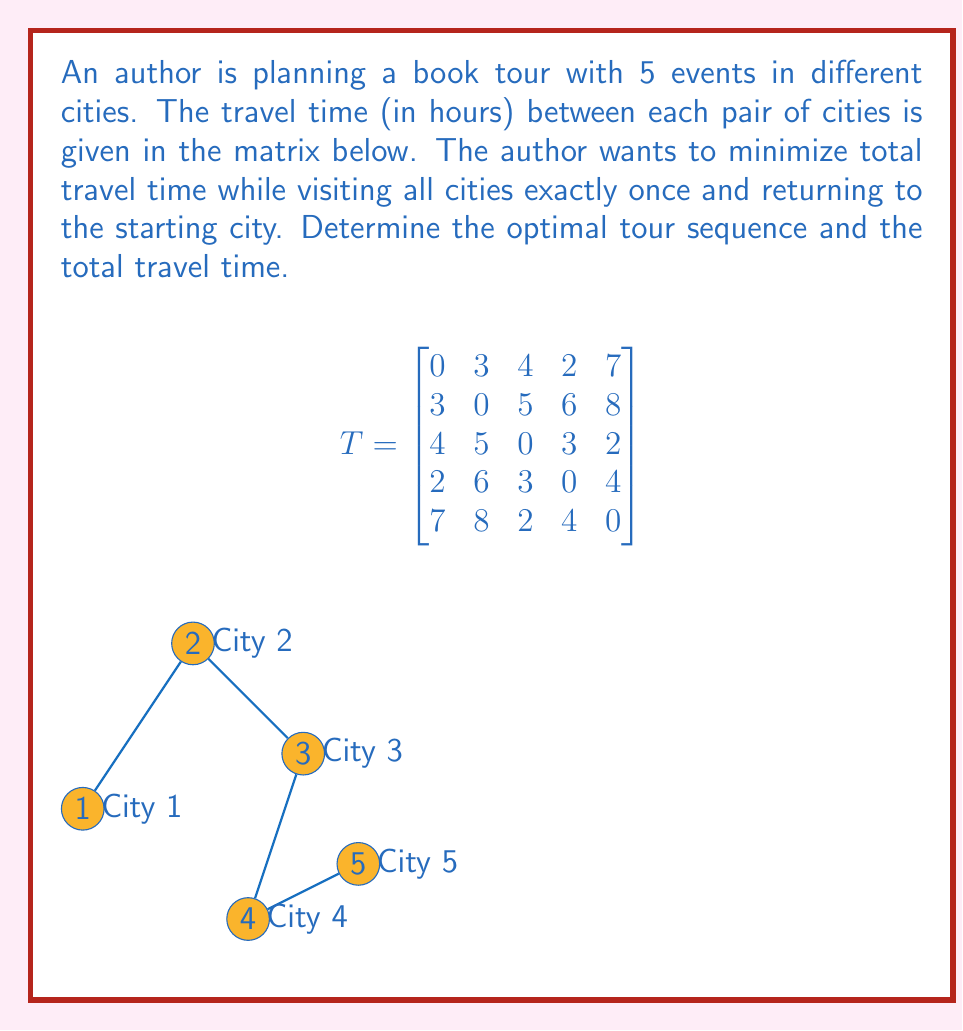Can you answer this question? This problem is an instance of the Traveling Salesman Problem (TSP), which can be solved using various methods. For a small number of cities like this, we can use the brute-force approach to find the optimal solution.

Steps:
1. List all possible tours: There are $(5-1)! = 24$ possible tours.
2. Calculate the total travel time for each tour.
3. Select the tour with the minimum total travel time.

Let's calculate a few examples:
Tour 1-2-3-4-5-1: $3 + 5 + 3 + 4 + 7 = 22$ hours
Tour 1-3-2-4-5-1: $4 + 5 + 6 + 4 + 7 = 26$ hours
...

After calculating all 24 possibilities, we find that the optimal tour is:
1-4-3-5-2-1

The total travel time for this tour is:
$$2 + 3 + 2 + 8 + 3 = 18$$ hours

This tour minimizes the total travel time while visiting all cities once and returning to the starting point.
Answer: Optimal tour: 1-4-3-5-2-1; Total travel time: 18 hours 